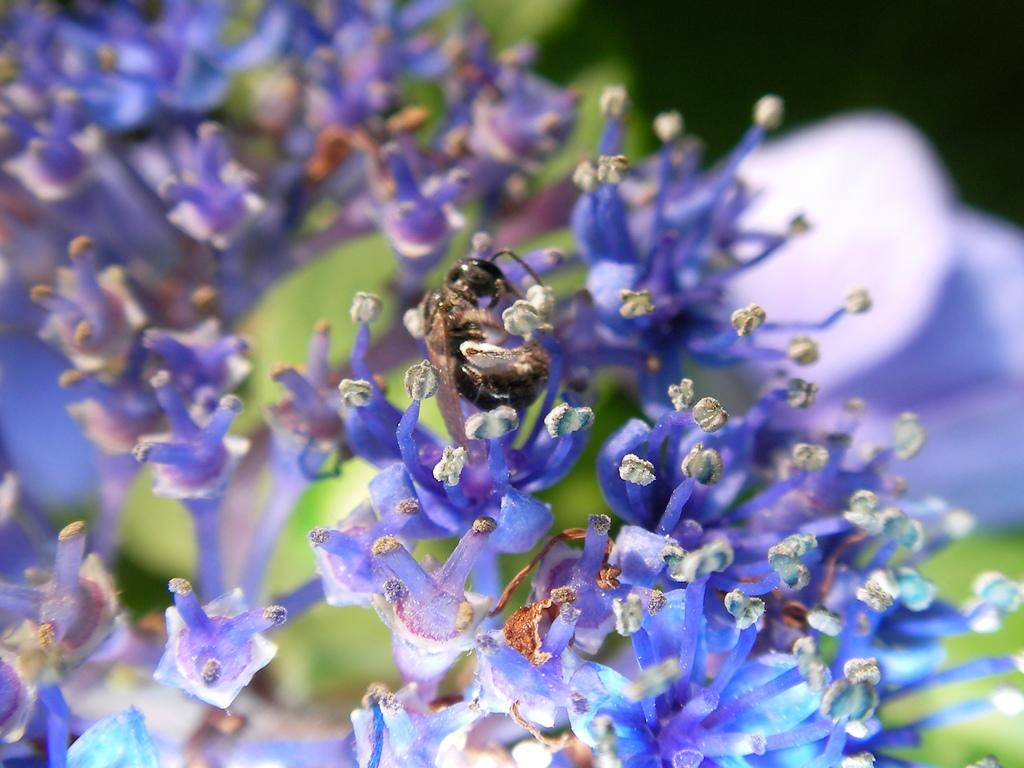What type of creature is present in the image? There is an insect in the image. Where is the insect located? The insect is on a plant. Can you describe the background of the image? The background of the image is blurred. How many spiders can be seen in the image? There are no spiders present in the image; it features an insect on a plant. What type of amusement is the insect providing in the image? The insect is not providing any amusement in the image; it is simply located on a plant. 